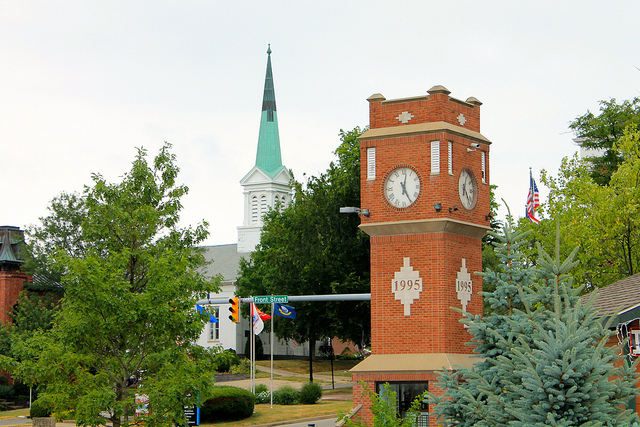Please extract the text content from this image. 1995 